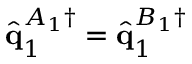<formula> <loc_0><loc_0><loc_500><loc_500>\hat { q } _ { 1 } ^ { A _ { 1 } \dagger } = \hat { q } _ { 1 } ^ { B _ { 1 } \dagger }</formula> 